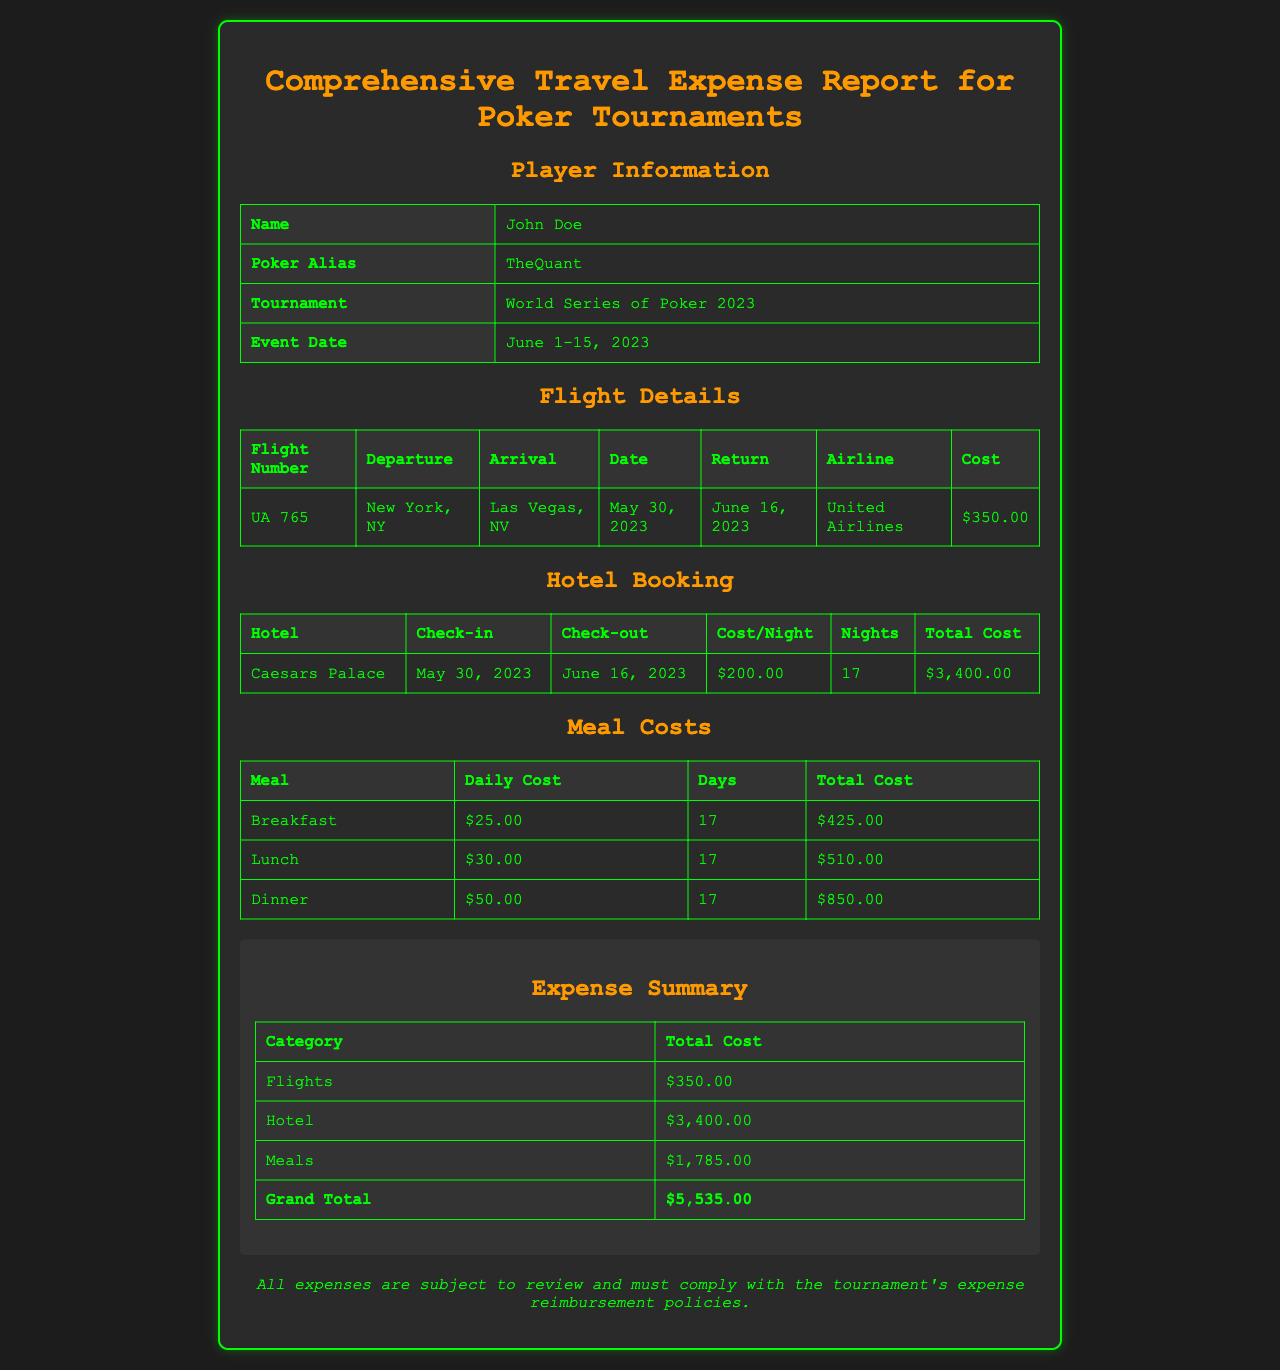What is the player's name? The player's name is listed in the Player Information section as John Doe.
Answer: John Doe What is the total cost of flights? The total cost of flights can be found in the Expense Summary section, which states $350.00.
Answer: $350.00 In which hotel did the player stay? The hotel name is provided in the Hotel Booking section, which is Caesars Palace.
Answer: Caesars Palace How many nights did the player stay at the hotel? The number of nights is listed in the Hotel Booking section as 17.
Answer: 17 What is the total meal cost? The total meal cost is summarized in the Expense Summary as $1,785.00.
Answer: $1,785.00 When is the check-out date? The check-out date for the hotel is found in the Hotel Booking section as June 16, 2023.
Answer: June 16, 2023 How much did breakfast cost daily? The daily cost for breakfast is stated in the Meal Costs section as $25.00.
Answer: $25.00 What is the grand total of expenses? The grand total of expenses is detailed in the Expense Summary as $5,535.00.
Answer: $5,535.00 Which airline was used for the flight? The airline is mentioned in the Flight Details section as United Airlines.
Answer: United Airlines 